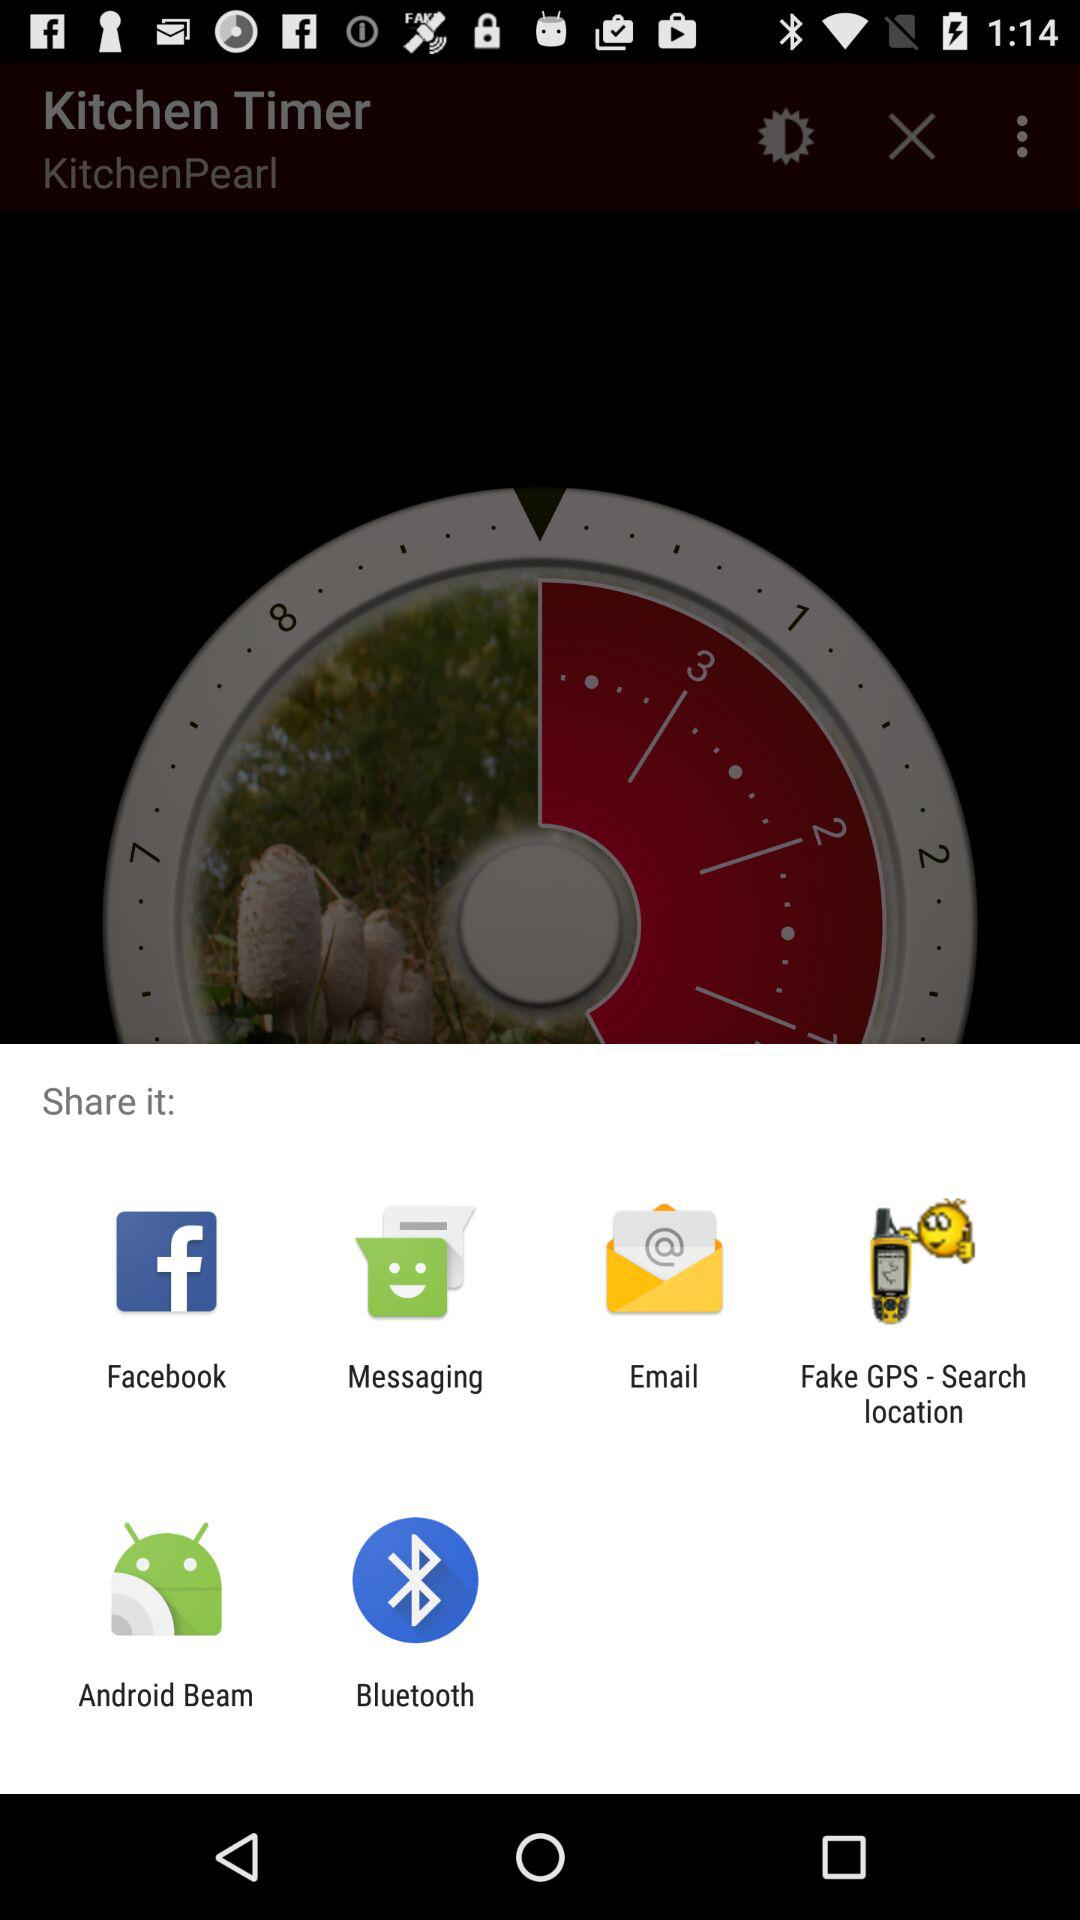Which options are given for sharing? The given options are "Facebook", "Messaging", "Email", "Fake GPS - Search location", "Android Beam" and "Bluetooth". 